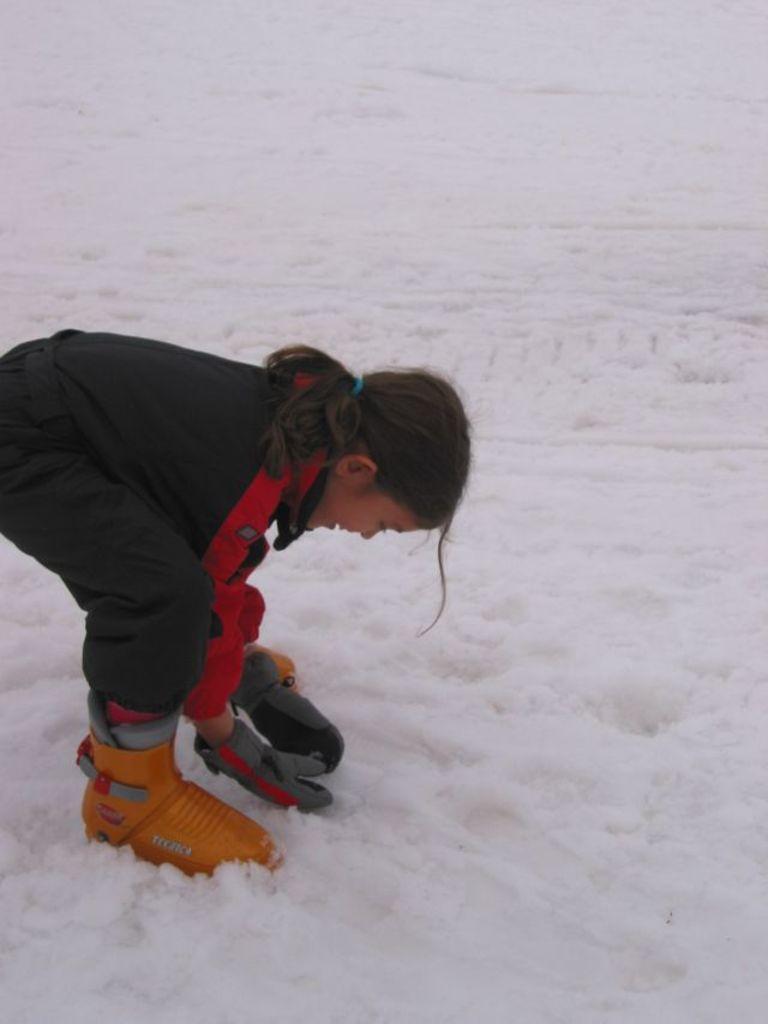How would you summarize this image in a sentence or two? In this image there is a little girl standing on the surface of the snow and she placed her hands above the snow. 